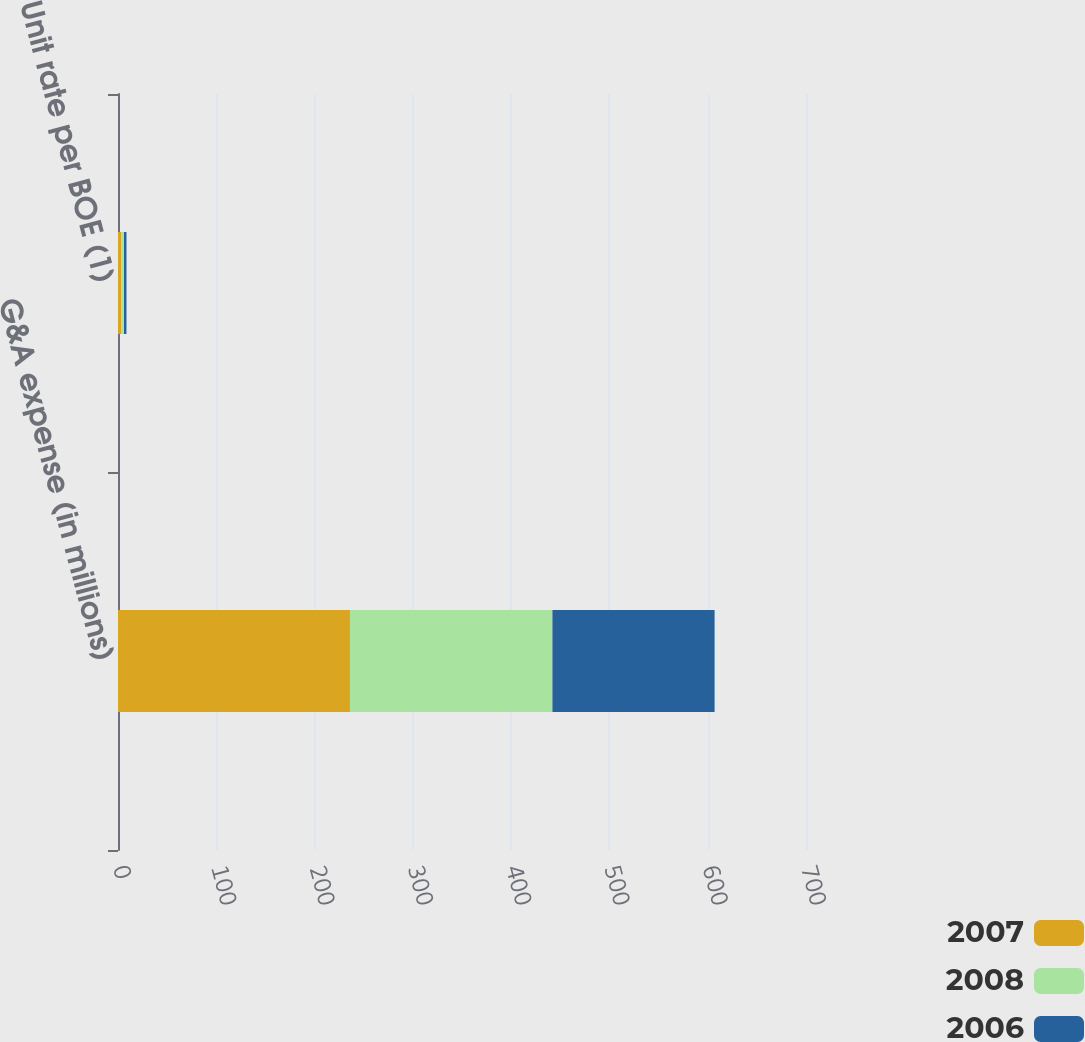Convert chart to OTSL. <chart><loc_0><loc_0><loc_500><loc_500><stacked_bar_chart><ecel><fcel>G&A expense (in millions)<fcel>Unit rate per BOE (1)<nl><fcel>2007<fcel>236<fcel>3.12<nl><fcel>2008<fcel>206<fcel>2.96<nl><fcel>2006<fcel>165<fcel>2.52<nl></chart> 